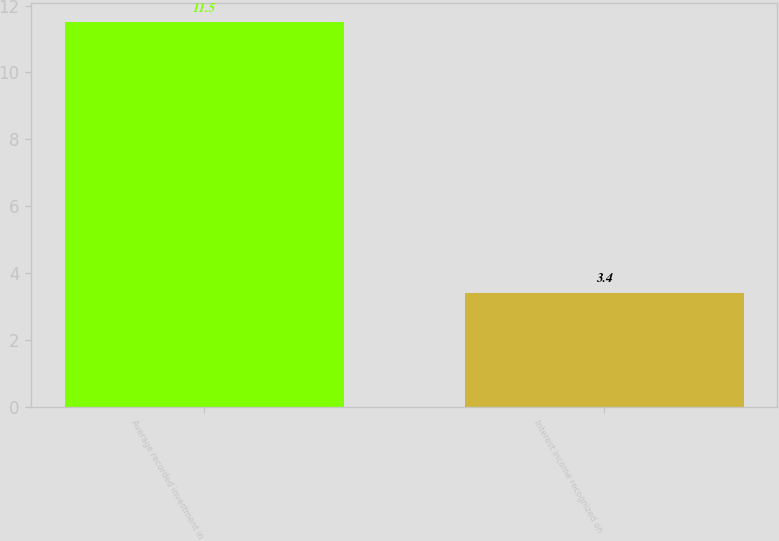<chart> <loc_0><loc_0><loc_500><loc_500><bar_chart><fcel>Average recorded investment in<fcel>Interest income recognized on<nl><fcel>11.5<fcel>3.4<nl></chart> 